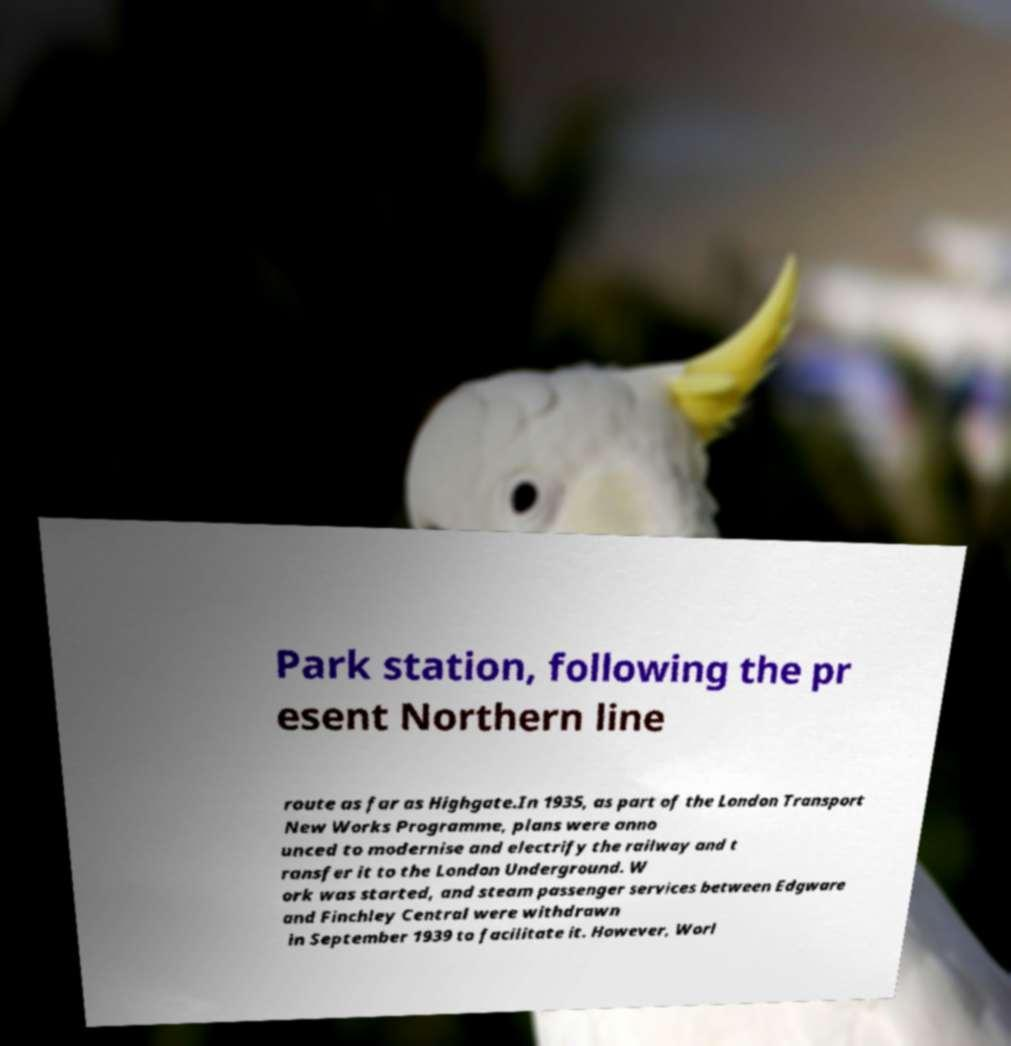Could you assist in decoding the text presented in this image and type it out clearly? Park station, following the pr esent Northern line route as far as Highgate.In 1935, as part of the London Transport New Works Programme, plans were anno unced to modernise and electrify the railway and t ransfer it to the London Underground. W ork was started, and steam passenger services between Edgware and Finchley Central were withdrawn in September 1939 to facilitate it. However, Worl 